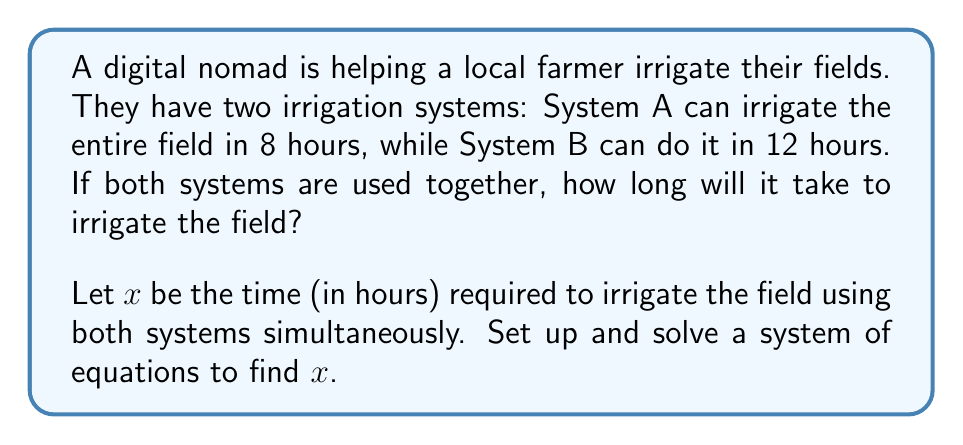Show me your answer to this math problem. Let's approach this step-by-step:

1) First, we need to understand what the question is asking. We're looking for the time it takes to irrigate the field when both systems are working together.

2) Let's define our variables:
   $x$ = time (in hours) to irrigate the field using both systems

3) Now, let's think about the rate at which each system works:
   - System A irrigates $\frac{1}{8}$ of the field per hour
   - System B irrigates $\frac{1}{12}$ of the field per hour

4) When both systems work together for $x$ hours, they should irrigate the entire field. We can express this as an equation:

   $$\frac{x}{8} + \frac{x}{12} = 1$$

5) This is our system of equations (although it's just one equation in this case). Let's solve it:

   $$\frac{3x}{24} + \frac{2x}{24} = 1$$ (finding a common denominator)

   $$\frac{5x}{24} = 1$$

6) Multiply both sides by 24:

   $$5x = 24$$

7) Divide both sides by 5:

   $$x = \frac{24}{5} = 4.8$$

Therefore, it will take 4.8 hours to irrigate the field using both systems together.
Answer: 4.8 hours 